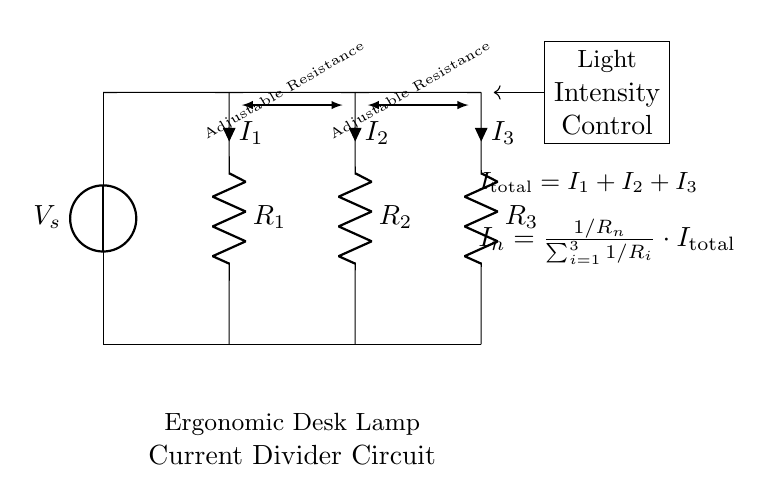What is the total current in this circuit? The total current, denoted as I_total, is the sum of the currents flowing through each resistor. According to Kirchhoff's current law, I_total = I_1 + I_2 + I_3 where I_1, I_2, and I_3 are the currents through resistors R_1, R_2, and R_3 respectively.
Answer: I_total What are the components in this circuit? The circuit consists of a voltage source, three resistors R_1, R_2, and R_3, and adjustable resistances for controlling light intensity. Each component can be identified visually in the circuit diagram.
Answer: Voltage source, R_1, R_2, R_3 How does the current divide among the resistors? The current divides based on the resistances of R_1, R_2, and R_3. Using the current divider formula, each current can be calculated as I_n = (1/R_n) / (sum of inverse resistances) * I_total. Each resistor's ability to divide current is inversely proportional to its resistance value.
Answer: Based on resistance values What is the purpose of adjustable resistance in this circuit? The adjustable resistance is used to control the intensity of the light emitted from the lamp. By changing the resistance, the current through the respective branch is altered, thereby adjusting the brightness of the light.
Answer: Light intensity control What is the relationship between resistance and current in a current divider? In a current divider, the current through each branch is inversely proportional to its resistance. A lower resistance allows more current to flow through that branch, while a higher resistance allows less current to flow. This principle is foundational for understanding how current is divided among parallel paths.
Answer: Inverse relationship What happens if one resistor is removed from the circuit? If one of the resistors (e.g., R_1) is removed, the remaining resistors (R_2 and R_3) will now receive the total current from the source. This means the current will redistribute itself between the remaining resistors based on their resistance values alone, which will change the light intensity for each.
Answer: Current redistributes 